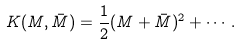<formula> <loc_0><loc_0><loc_500><loc_500>K ( M , \bar { M } ) = \frac { 1 } { 2 } ( M + \bar { M } ) ^ { 2 } + \cdots .</formula> 